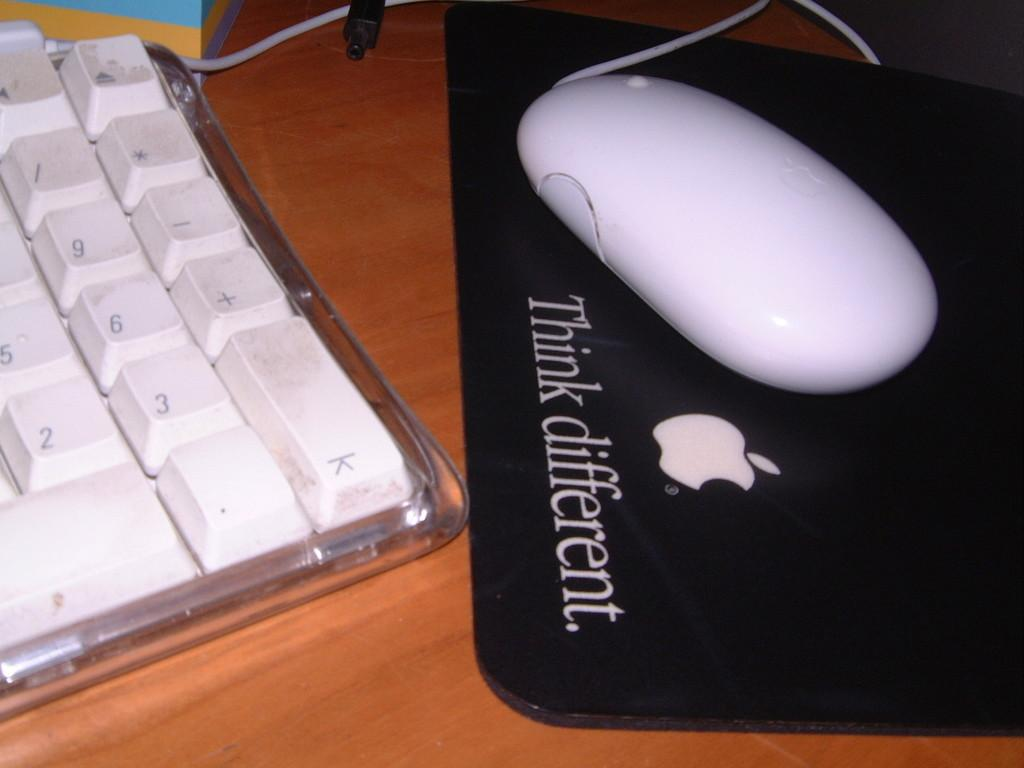<image>
Summarize the visual content of the image. a white apple mouse on top of a pad that is labeled 'think different.' 